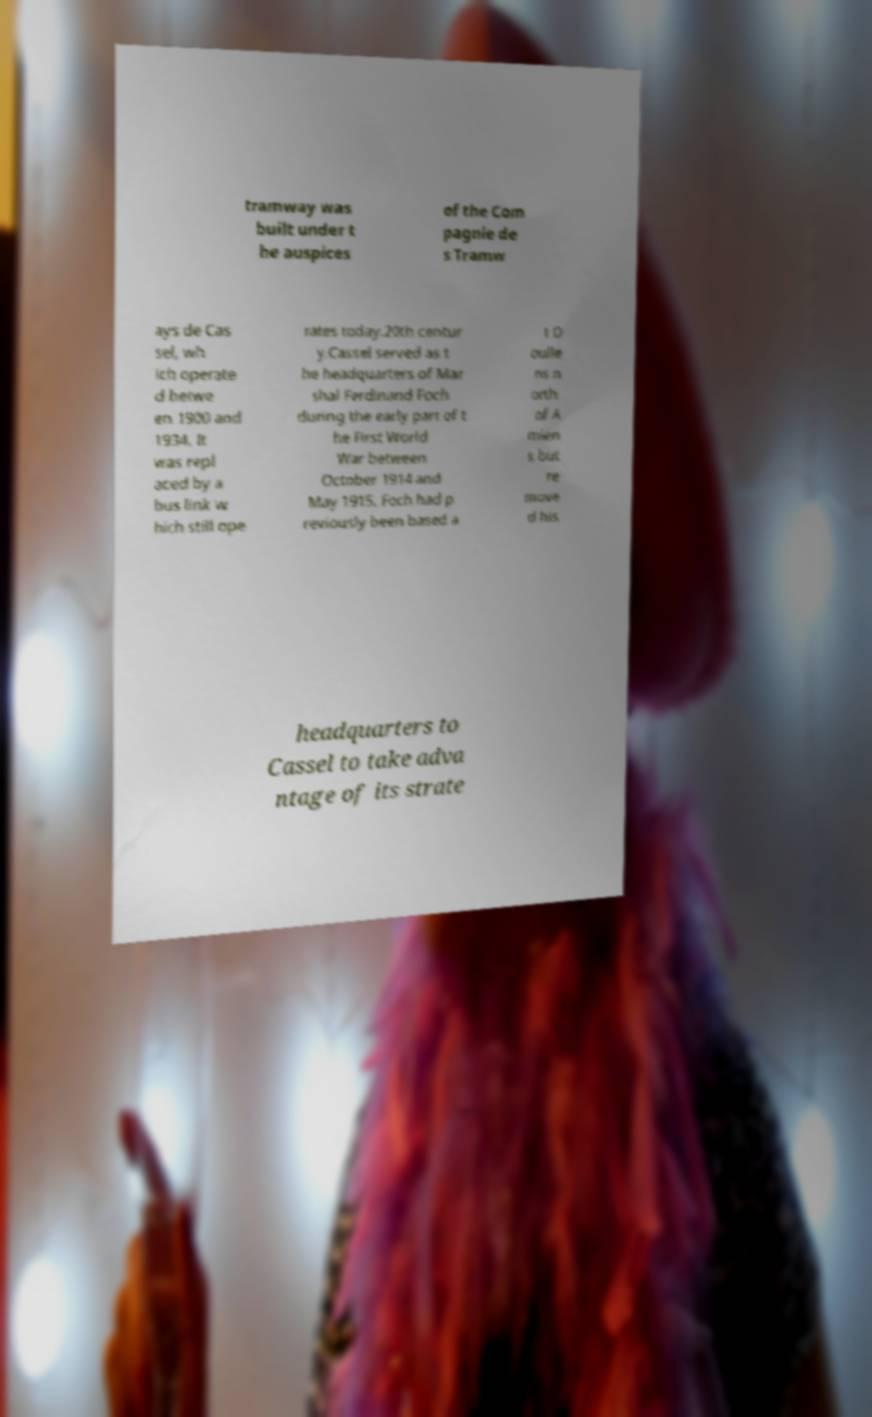Could you assist in decoding the text presented in this image and type it out clearly? tramway was built under t he auspices of the Com pagnie de s Tramw ays de Cas sel, wh ich operate d betwe en 1900 and 1934. It was repl aced by a bus link w hich still ope rates today.20th centur y.Cassel served as t he headquarters of Mar shal Ferdinand Foch during the early part of t he First World War between October 1914 and May 1915. Foch had p reviously been based a t D oulle ns n orth of A mien s but re move d his headquarters to Cassel to take adva ntage of its strate 